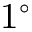<formula> <loc_0><loc_0><loc_500><loc_500>1 ^ { \circ }</formula> 